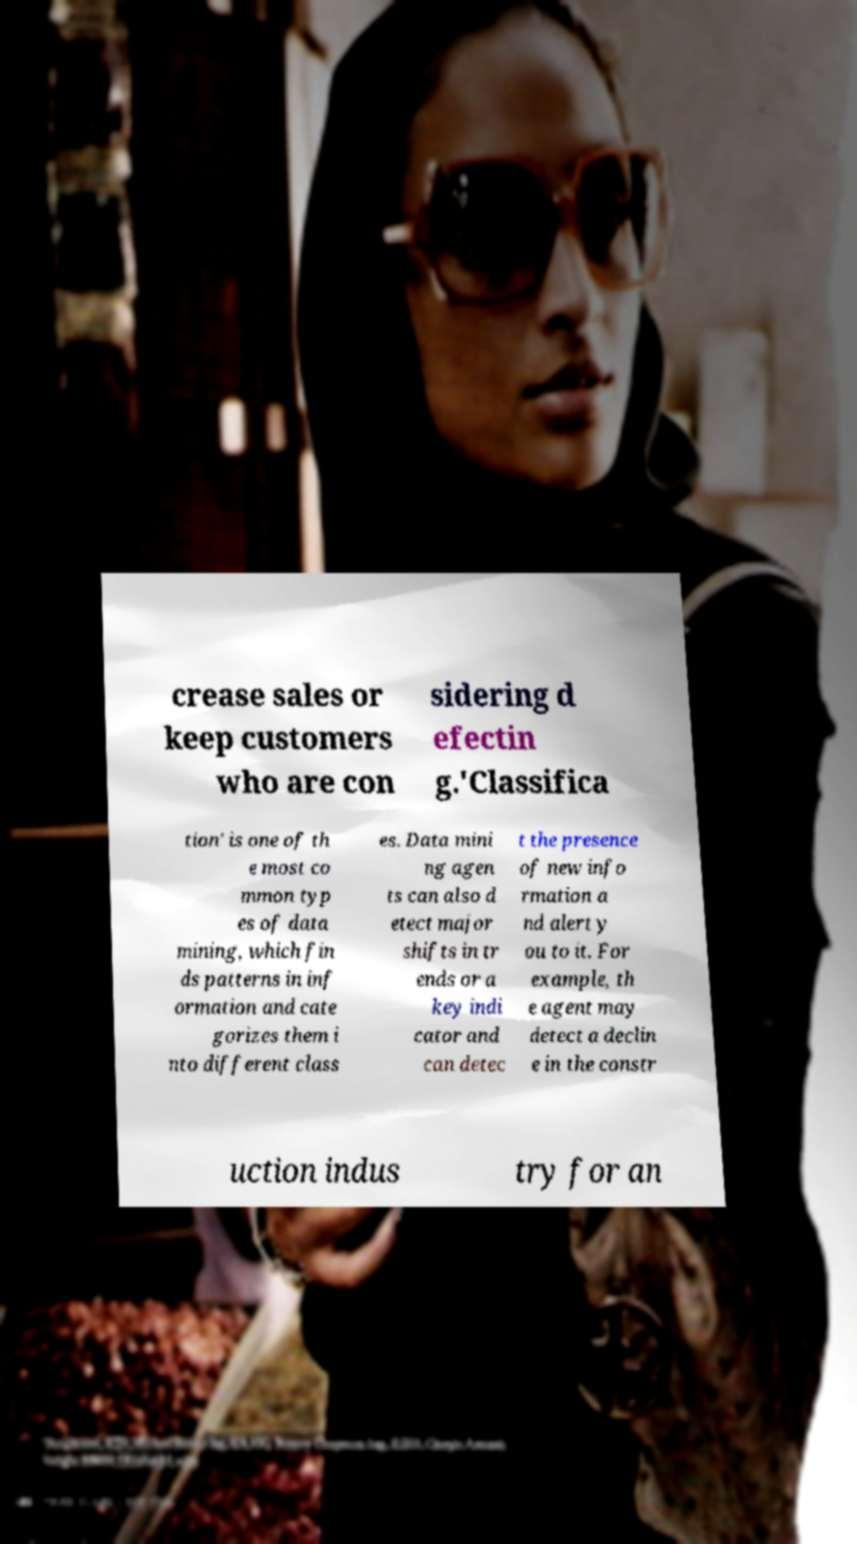Can you read and provide the text displayed in the image?This photo seems to have some interesting text. Can you extract and type it out for me? crease sales or keep customers who are con sidering d efectin g.'Classifica tion' is one of th e most co mmon typ es of data mining, which fin ds patterns in inf ormation and cate gorizes them i nto different class es. Data mini ng agen ts can also d etect major shifts in tr ends or a key indi cator and can detec t the presence of new info rmation a nd alert y ou to it. For example, th e agent may detect a declin e in the constr uction indus try for an 